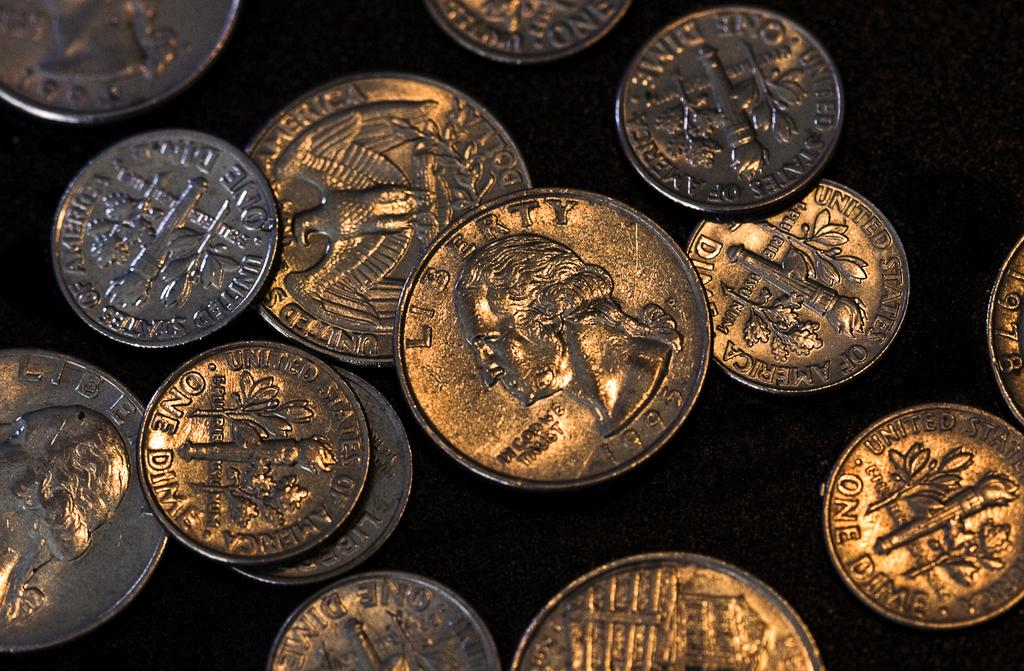<image>
Provide a brief description of the given image. Many coins together on a table including one dime coins. 